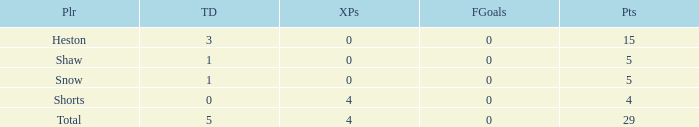What is the overall sum of field goals for a player who scored under 3 touchdowns, earned 4 points, and achieved fewer than 4 extra points? 0.0. 